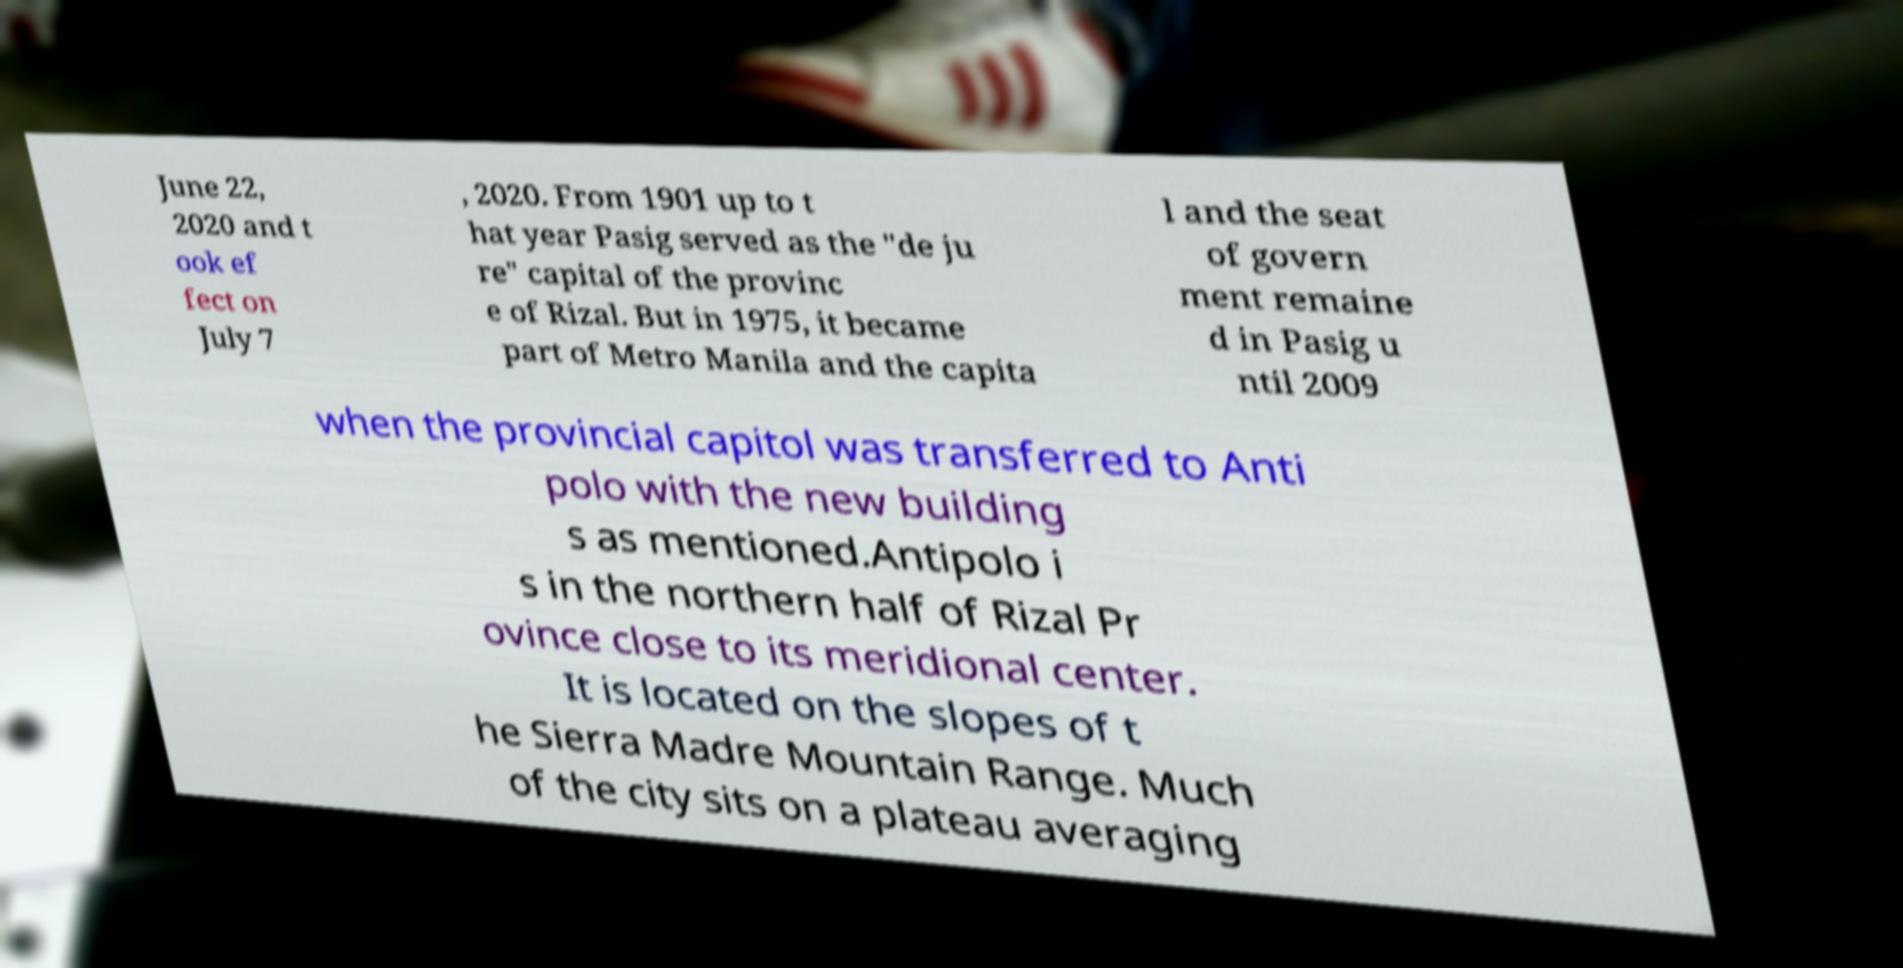Could you assist in decoding the text presented in this image and type it out clearly? June 22, 2020 and t ook ef fect on July 7 , 2020. From 1901 up to t hat year Pasig served as the "de ju re" capital of the provinc e of Rizal. But in 1975, it became part of Metro Manila and the capita l and the seat of govern ment remaine d in Pasig u ntil 2009 when the provincial capitol was transferred to Anti polo with the new building s as mentioned.Antipolo i s in the northern half of Rizal Pr ovince close to its meridional center. It is located on the slopes of t he Sierra Madre Mountain Range. Much of the city sits on a plateau averaging 